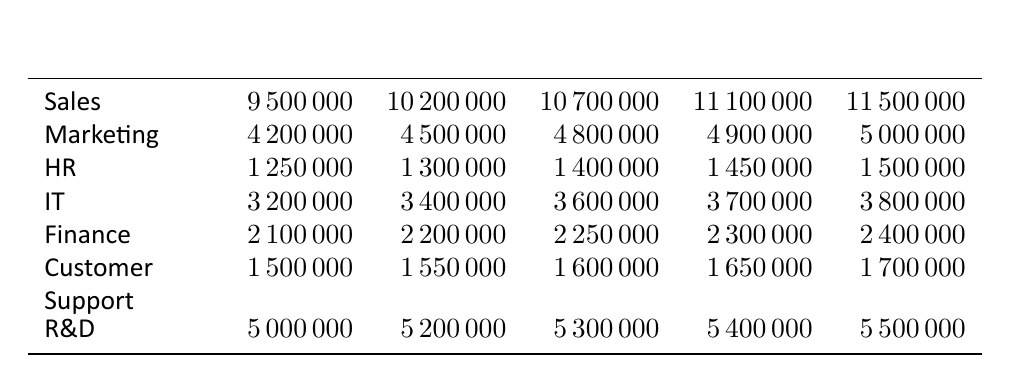What was the total revenue for the Sales department in 2021? The revenue for the Sales department in 2021 is listed as 11,100,000.
Answer: 11,100,000 Which department had the highest revenue in 2020? In 2020, the Sales department had a revenue of 10,700,000, while R&D had 5,300,000, making Sales the highest at 10,700,000.
Answer: Sales What was the percentage increase in revenue for the IT department from 2018 to 2022? The revenue for IT in 2018 was 3,200,000 and in 2022 was 3,800,000. The increase is 3,800,000 - 3,200,000 = 600,000. The percentage increase is (600,000 / 3,200,000) * 100 = 18.75%.
Answer: 18.75% Did the Finance department's revenue ever decrease over the five years? The Finance department's revenue increased every year from 2,100,000 in 2018 to 2,400,000 in 2022, indicating no years of decrease.
Answer: No What was the average revenue for Customer Support over these five years? The revenues for Customer Support are 1,500,000 in 2018, 1,550,000 in 2019, 1,600,000 in 2020, 1,650,000 in 2021, and 1,700,000 in 2022. The total is 1,500,000 + 1,550,000 + 1,600,000 + 1,650,000 + 1,700,000 = 8,000,000. The average is 8,000,000 / 5 = 1,600,000.
Answer: 1,600,000 If we sum up the revenues for all departments in 2019, what is the total? The revenues for all departments in 2019 are: Sales 10,200,000 + Marketing 4,500,000 + HR 1,300,000 + IT 3,400,000 + Finance 2,200,000 + Customer Support 1,550,000 + R&D 5,200,000. The total is 10,200,000 + 4,500,000 + 1,300,000 + 3,400,000 + 2,200,000 + 1,550,000 + 5,200,000 = 28,350,000.
Answer: 28,350,000 